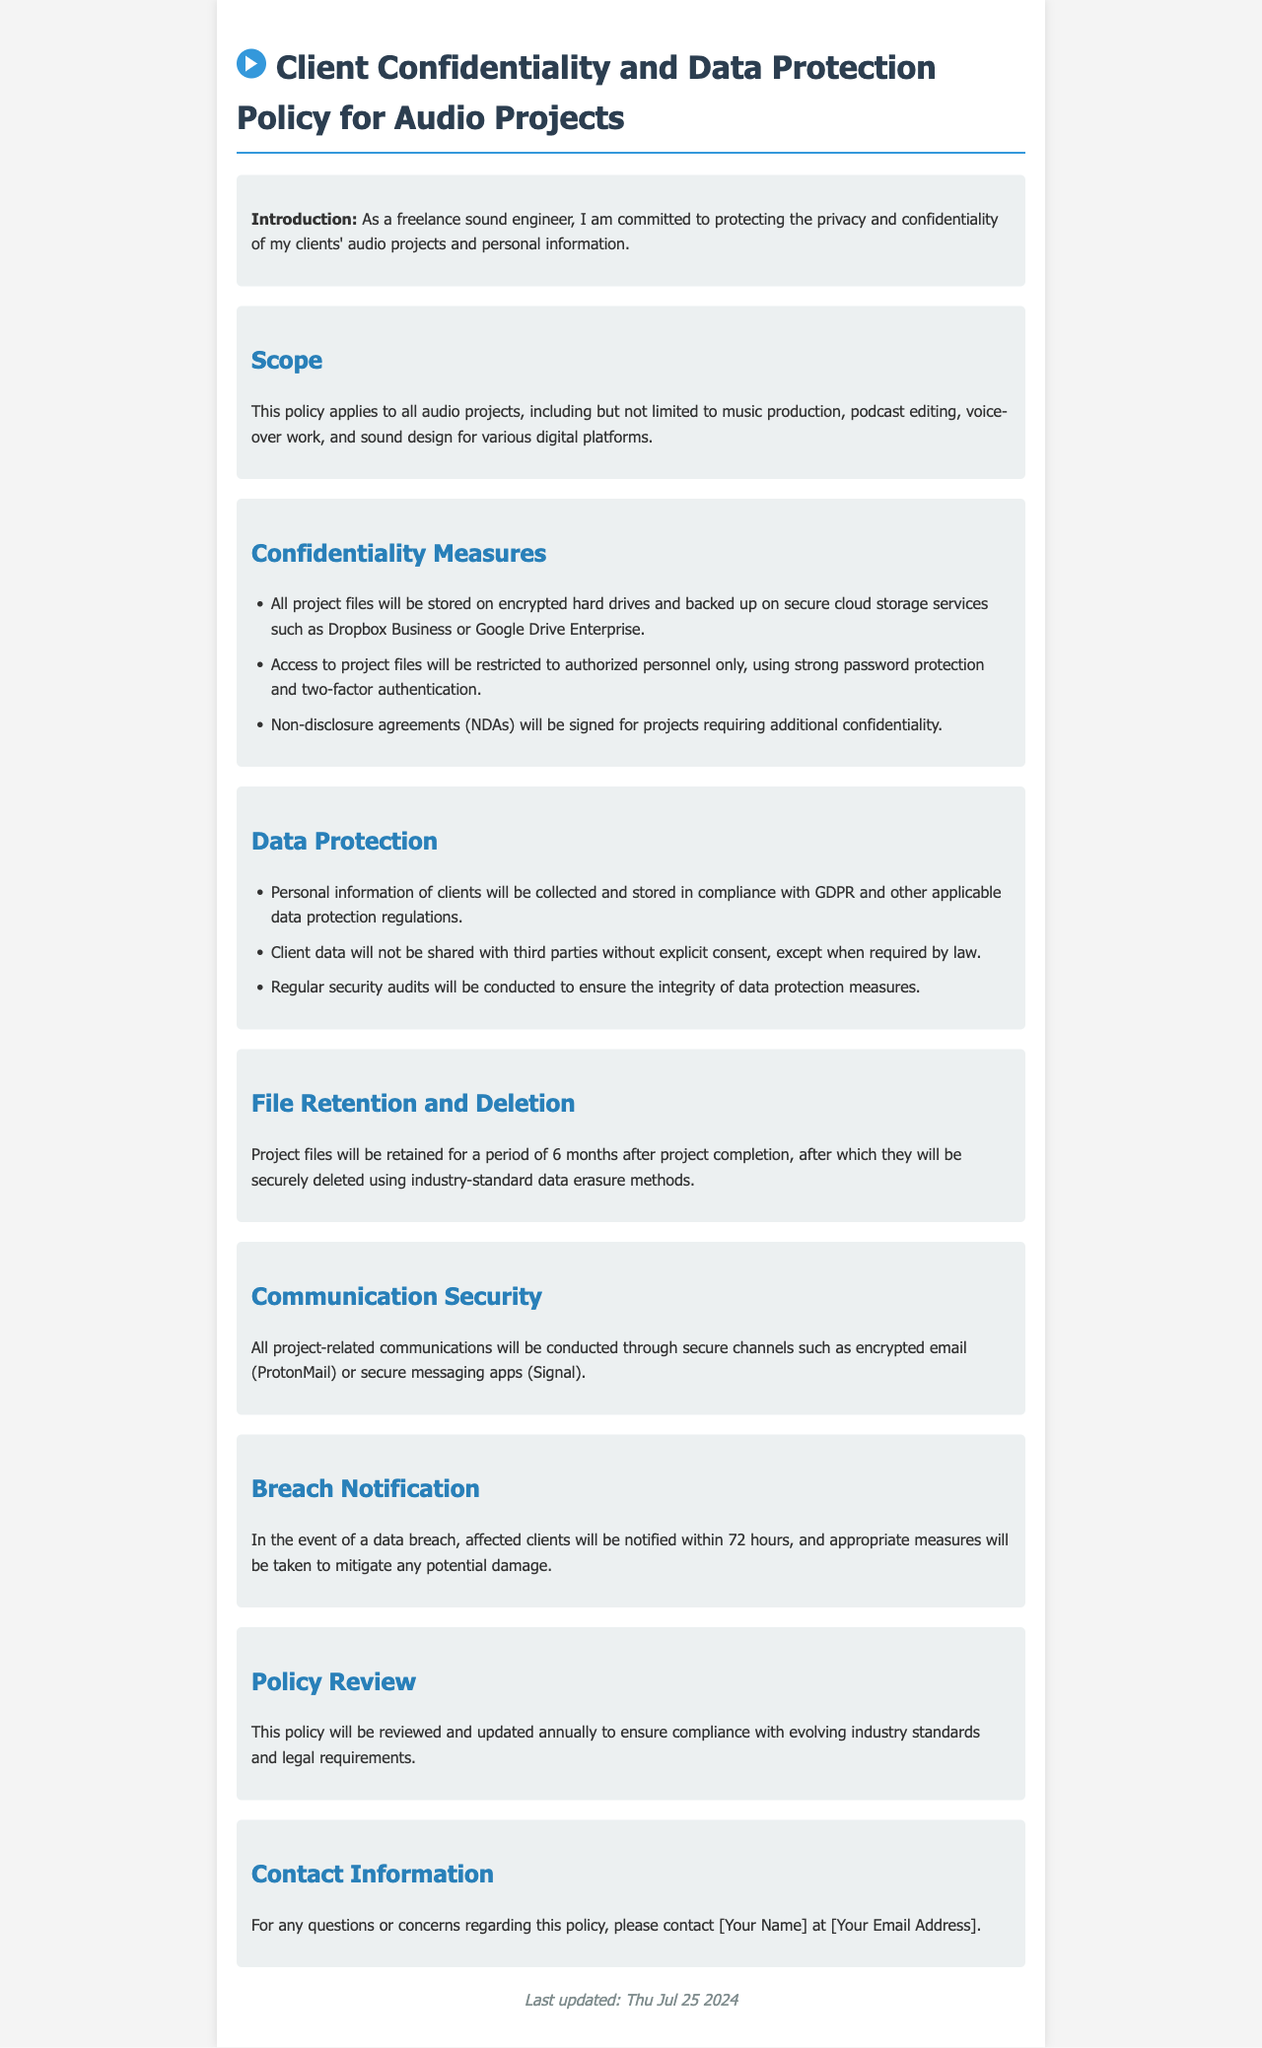What is the title of the policy document? The title of the policy document can be found at the top of the document, stating its purpose.
Answer: Client Confidentiality and Data Protection Policy for Audio Projects How long will project files be retained after completion? The retention period of project files is mentioned in the document under the File Retention and Deletion section.
Answer: 6 months Which cloud storage services are mentioned for backing up project files? The document lists specific cloud storage services used for secure backup of project files.
Answer: Dropbox Business or Google Drive Enterprise What will happen in the event of a data breach? The document explains the procedure to be followed in case of a data breach in the Breach Notification section.
Answer: Affected clients will be notified within 72 hours What is the main commitment of the sound engineer regarding client information? The introduction section highlights the primary focus of the sound engineer in relation to client information.
Answer: Protecting privacy and confidentiality What method will be used for deleting project files after retention? The document specifies the approach taken to securely delete files once the retention period has expired.
Answer: Industry-standard data erasure methods 